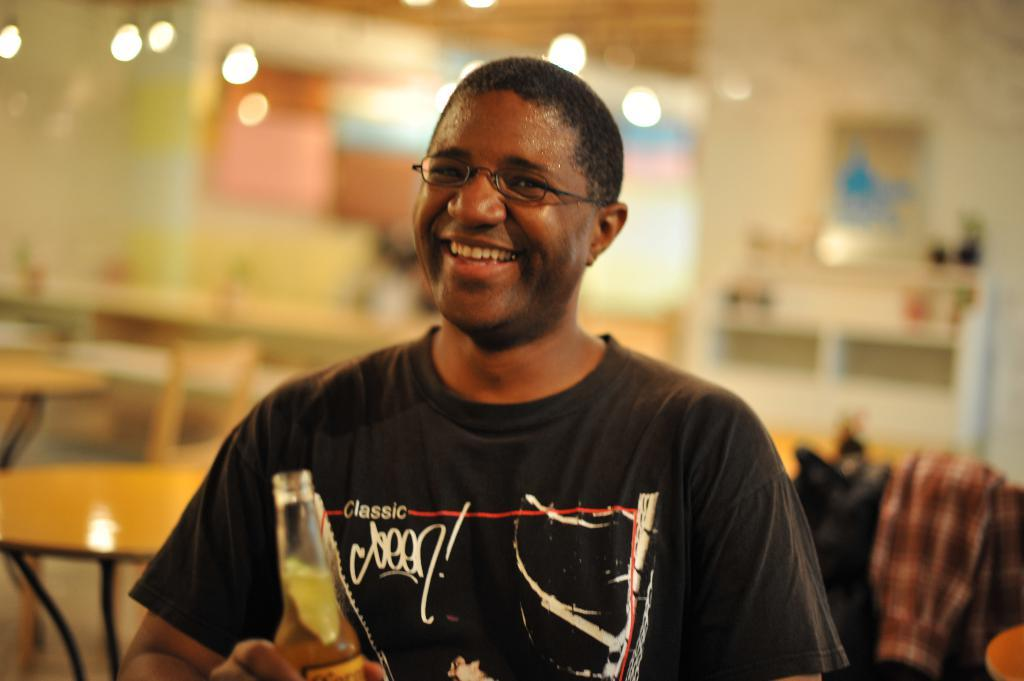What is present in the image? There is a man in the image. What is the man holding in his hand? The man is holding an object in his hand. How is the man's facial expression in the image? The man is smiling. What type of train can be seen in the background of the image? There is no train present in the image. What kind of doll is sitting on the man's shoulder in the image? There is no doll present in the image. How many sheep are visible in the image? There are no sheep present in the image. 